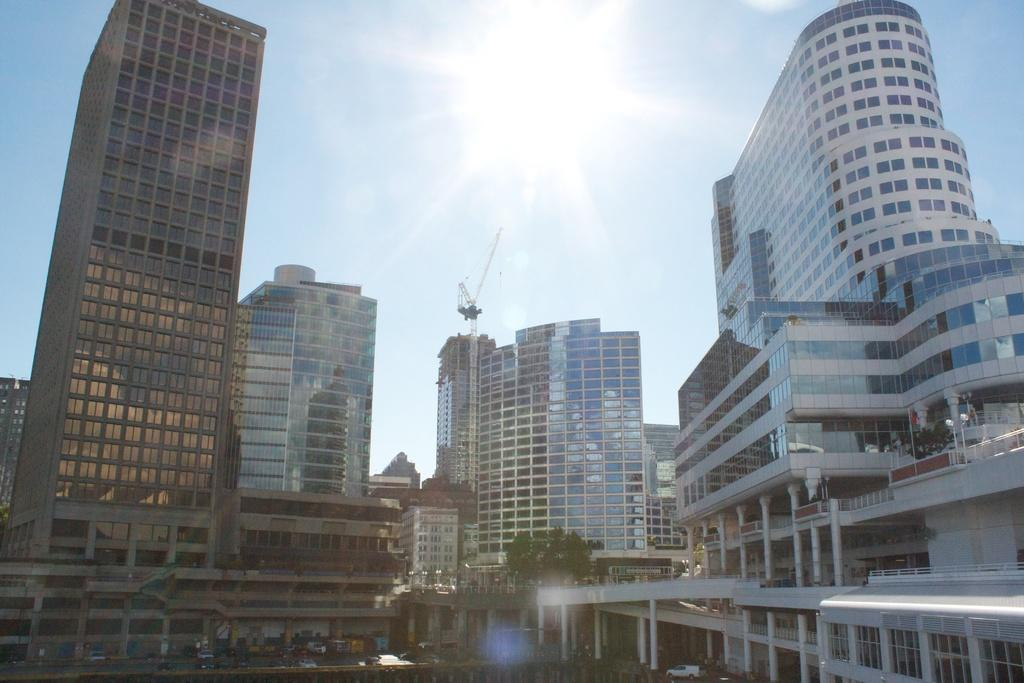What type of structures can be seen in the image? There are buildings in the image. What else can be seen on the ground in the image? There are vehicles on the road in the image. What type of vegetation is present in the image? There are trees in the image. What is visible in the background of the image? The sky is visible in the background of the image. Can you tell me how many inventions are displayed in the image? There is no invention present in the image; it features buildings, vehicles, trees, and the sky. Is there a sea visible in the image? There is no sea present in the image; it features buildings, vehicles, trees, and the sky. 